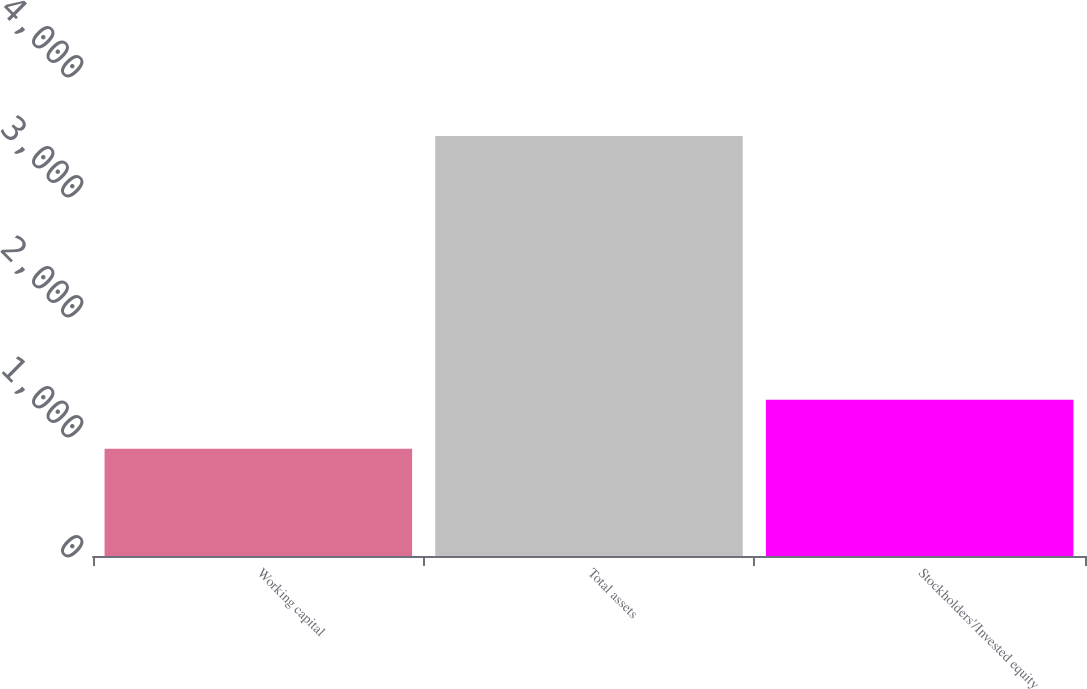Convert chart. <chart><loc_0><loc_0><loc_500><loc_500><bar_chart><fcel>Working capital<fcel>Total assets<fcel>Stockholders'/Invested equity<nl><fcel>893<fcel>3501<fcel>1302<nl></chart> 